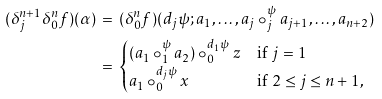Convert formula to latex. <formula><loc_0><loc_0><loc_500><loc_500>( \delta ^ { n + 1 } _ { j } \delta ^ { n } _ { 0 } f ) ( \alpha ) & \, = \, ( \delta ^ { n } _ { 0 } f ) ( d _ { j } \psi ; a _ { 1 } , \dots , a _ { j } \circ ^ { \psi } _ { j } a _ { j + 1 } , \dots , a _ { n + 2 } ) \\ & \, = \, \begin{cases} ( a _ { 1 } \circ ^ { \psi } _ { 1 } a _ { 2 } ) \circ ^ { d _ { 1 } \psi } _ { 0 } z & \text {if } j = 1 \\ a _ { 1 } \circ ^ { d _ { j } \psi } _ { 0 } x & \text {if } 2 \leq j \leq n + 1 , \end{cases}</formula> 